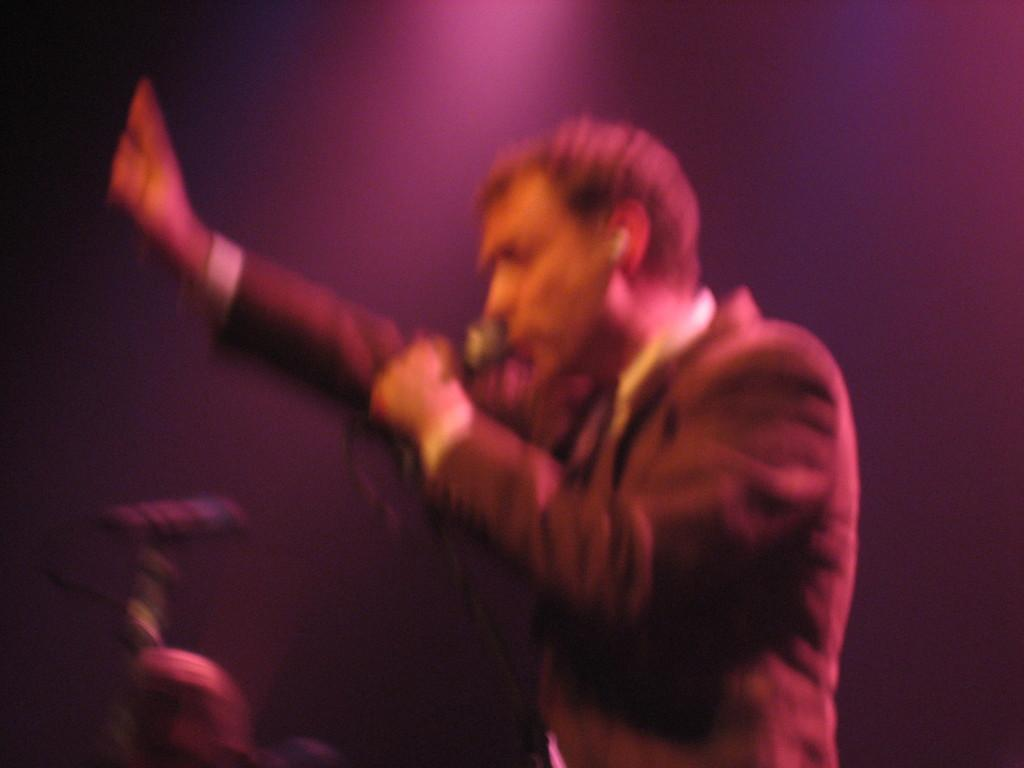Who is present in the image? There is a person in the image. What is the person holding in the image? The person is holding a mic. Can you describe the objects in the image? There are objects in the image, but their specific details are not mentioned in the provided facts. What is the color of the background in the image? The background of the image is dark. What time of day is it in the image? The provided facts do not mention the time of day, so it cannot be determined from the image. Is there an alley visible in the image? There is no mention of an alley in the provided facts, so it cannot be determined from the image. 